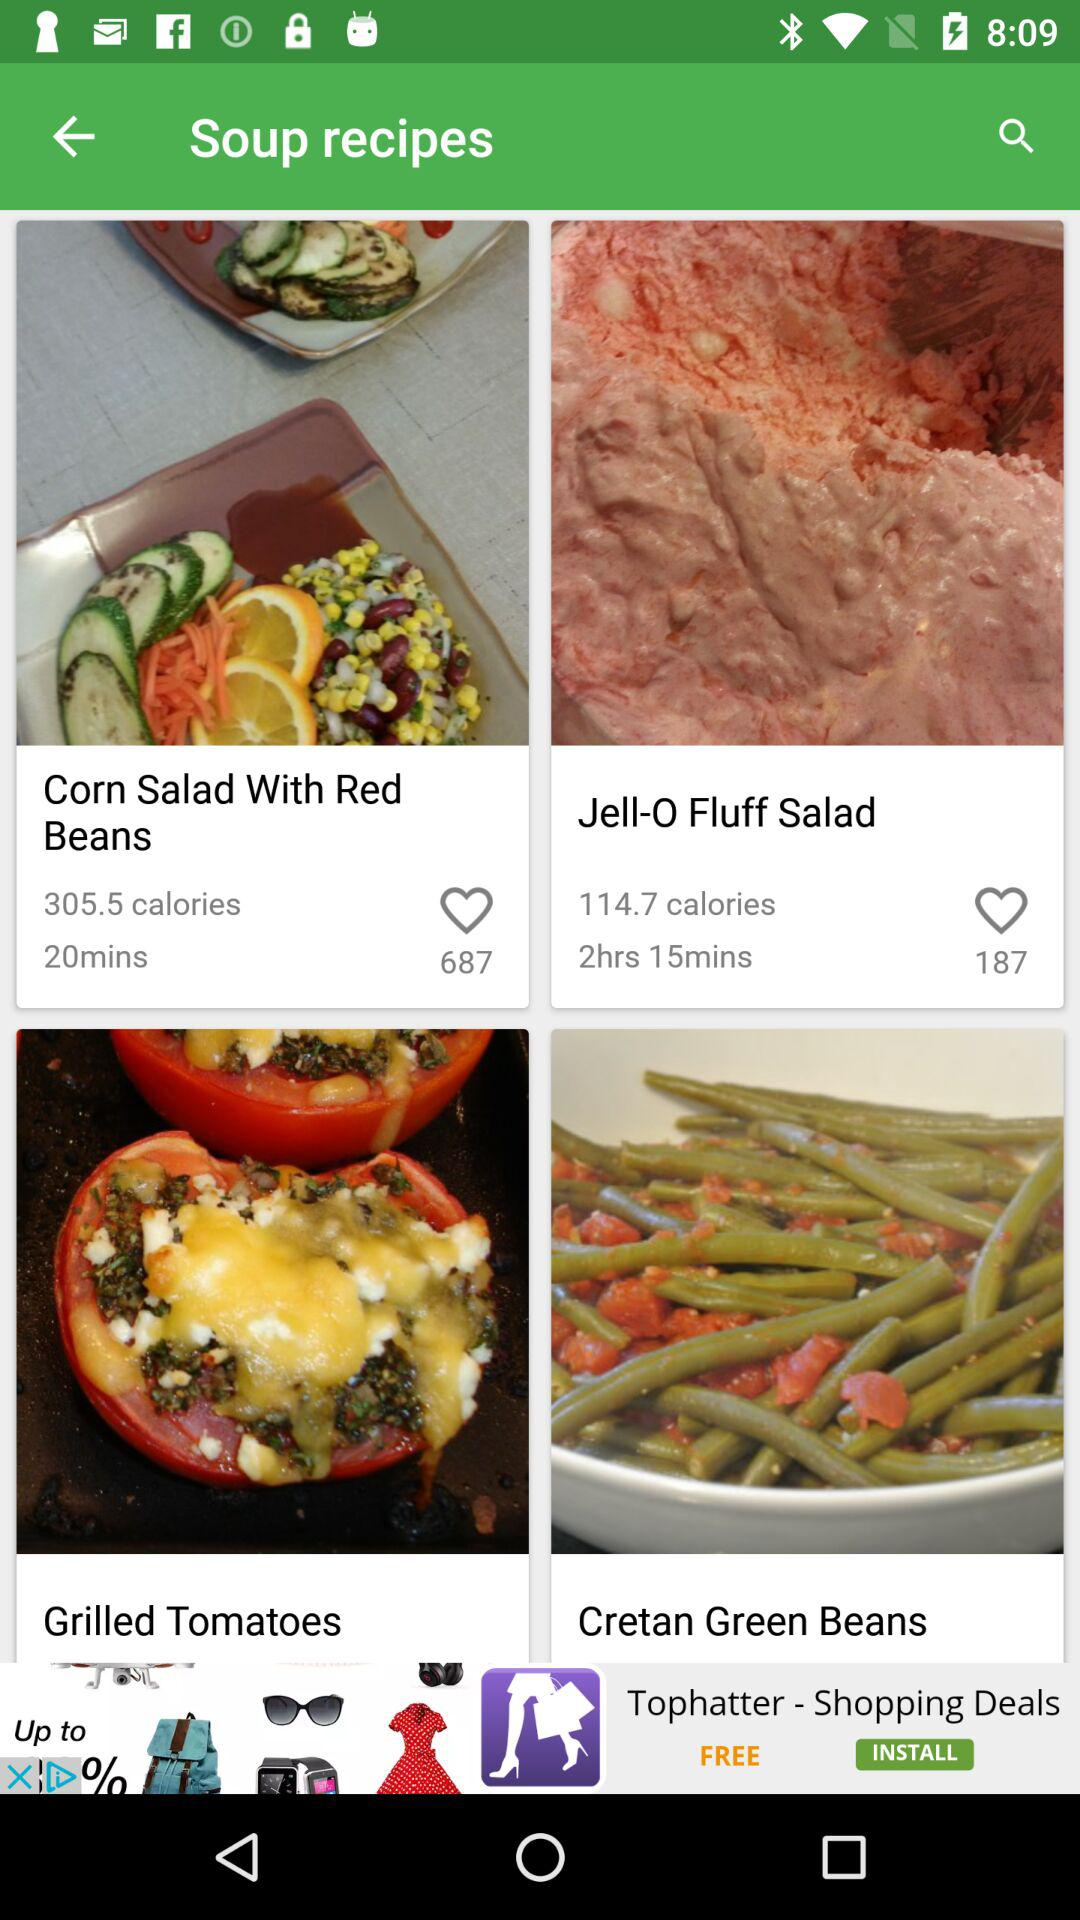How many people liked "Jell-O Fluff Salad"? "Jell-O Fluff Salad" was liked by 187 people. 